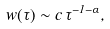<formula> <loc_0><loc_0><loc_500><loc_500>w ( \tau ) \sim c \, \tau ^ { - 1 - \alpha } ,</formula> 